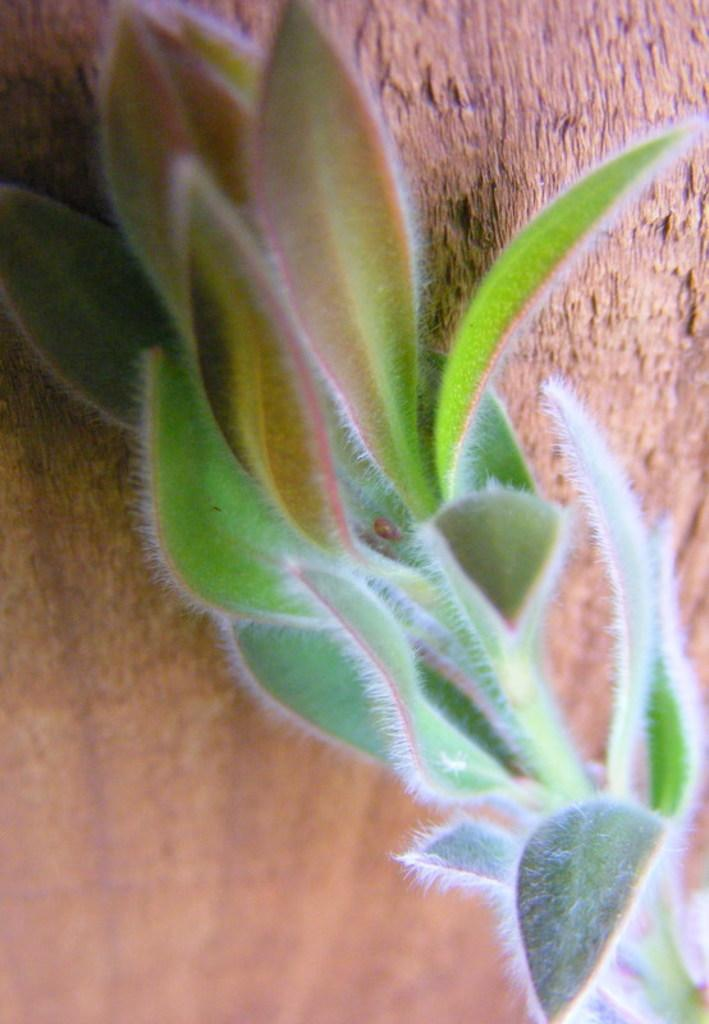What type of vegetation can be seen in the image? There is a plant in the image. Where is the plant located in relation to the image? The plant is in the front of the image. What other type of vegetation can be seen in the image? There is a tree in the background of the image. What type of jam is being spread on the plant in the image? There is no jam or any indication of spreading in the image; it features a plant and a tree. 